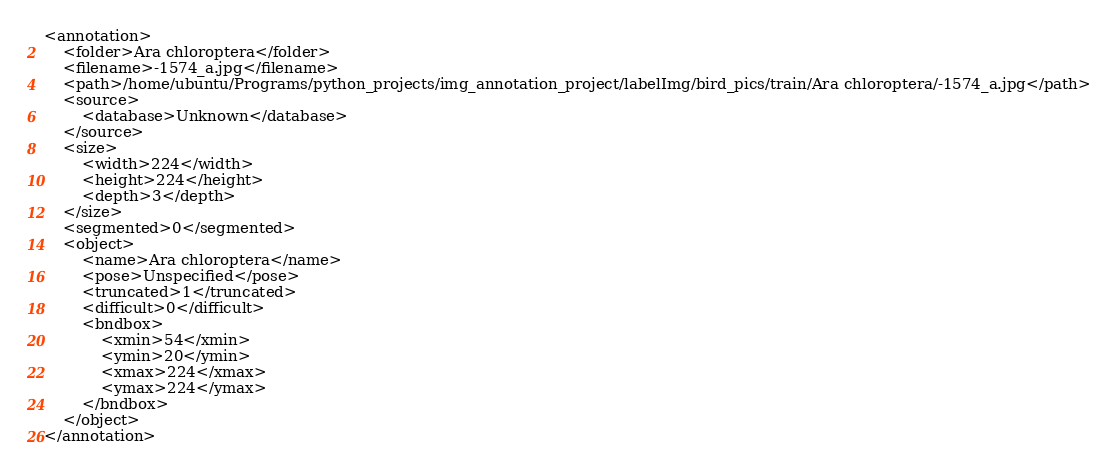Convert code to text. <code><loc_0><loc_0><loc_500><loc_500><_XML_><annotation>
	<folder>Ara chloroptera</folder>
	<filename>-1574_a.jpg</filename>
	<path>/home/ubuntu/Programs/python_projects/img_annotation_project/labelImg/bird_pics/train/Ara chloroptera/-1574_a.jpg</path>
	<source>
		<database>Unknown</database>
	</source>
	<size>
		<width>224</width>
		<height>224</height>
		<depth>3</depth>
	</size>
	<segmented>0</segmented>
	<object>
		<name>Ara chloroptera</name>
		<pose>Unspecified</pose>
		<truncated>1</truncated>
		<difficult>0</difficult>
		<bndbox>
			<xmin>54</xmin>
			<ymin>20</ymin>
			<xmax>224</xmax>
			<ymax>224</ymax>
		</bndbox>
	</object>
</annotation>
</code> 